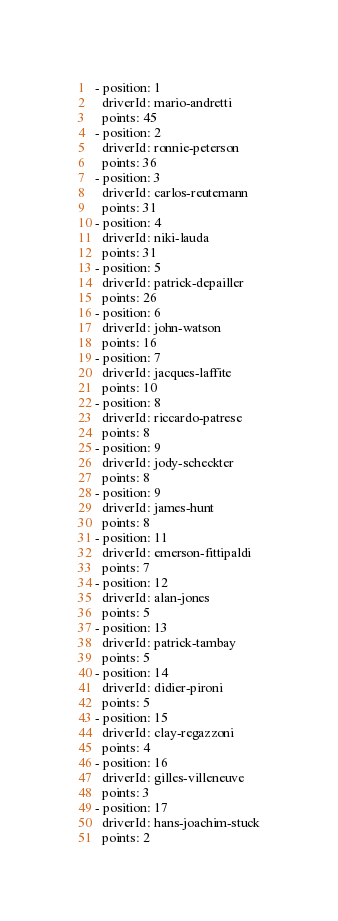Convert code to text. <code><loc_0><loc_0><loc_500><loc_500><_YAML_>- position: 1
  driverId: mario-andretti
  points: 45
- position: 2
  driverId: ronnie-peterson
  points: 36
- position: 3
  driverId: carlos-reutemann
  points: 31
- position: 4
  driverId: niki-lauda
  points: 31
- position: 5
  driverId: patrick-depailler
  points: 26
- position: 6
  driverId: john-watson
  points: 16
- position: 7
  driverId: jacques-laffite
  points: 10
- position: 8
  driverId: riccardo-patrese
  points: 8
- position: 9
  driverId: jody-scheckter
  points: 8
- position: 9
  driverId: james-hunt
  points: 8
- position: 11
  driverId: emerson-fittipaldi
  points: 7
- position: 12
  driverId: alan-jones
  points: 5
- position: 13
  driverId: patrick-tambay
  points: 5
- position: 14
  driverId: didier-pironi
  points: 5
- position: 15
  driverId: clay-regazzoni
  points: 4
- position: 16
  driverId: gilles-villeneuve
  points: 3
- position: 17
  driverId: hans-joachim-stuck
  points: 2
</code> 